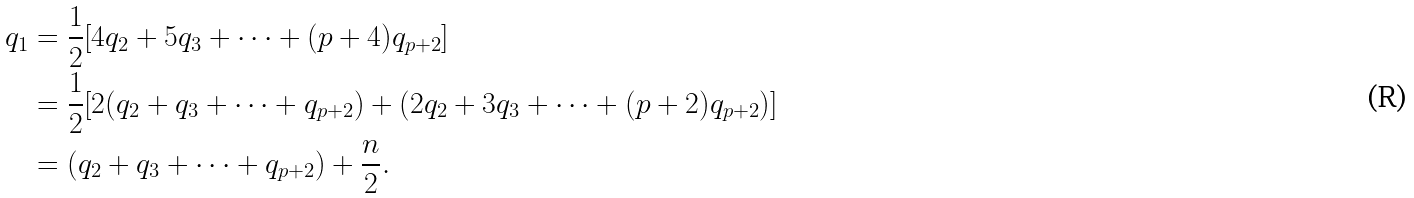Convert formula to latex. <formula><loc_0><loc_0><loc_500><loc_500>q _ { 1 } & = \frac { 1 } { 2 } [ 4 q _ { 2 } + 5 q _ { 3 } + \cdots + ( p + 4 ) q _ { p + 2 } ] \\ & = \frac { 1 } { 2 } [ 2 ( q _ { 2 } + q _ { 3 } + \cdots + q _ { p + 2 } ) + ( 2 q _ { 2 } + 3 q _ { 3 } + \cdots + ( p + 2 ) q _ { p + 2 } ) ] \\ & = ( q _ { 2 } + q _ { 3 } + \cdots + q _ { p + 2 } ) + \frac { n } { 2 } .</formula> 